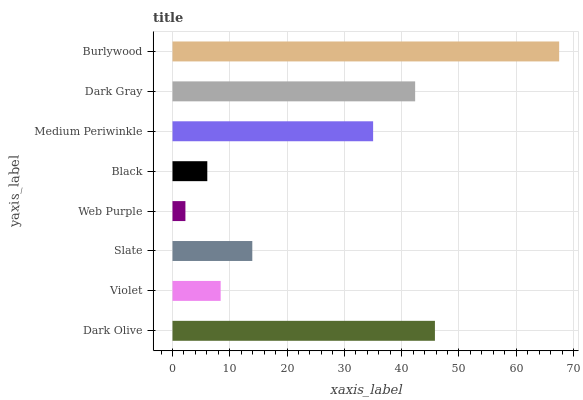Is Web Purple the minimum?
Answer yes or no. Yes. Is Burlywood the maximum?
Answer yes or no. Yes. Is Violet the minimum?
Answer yes or no. No. Is Violet the maximum?
Answer yes or no. No. Is Dark Olive greater than Violet?
Answer yes or no. Yes. Is Violet less than Dark Olive?
Answer yes or no. Yes. Is Violet greater than Dark Olive?
Answer yes or no. No. Is Dark Olive less than Violet?
Answer yes or no. No. Is Medium Periwinkle the high median?
Answer yes or no. Yes. Is Slate the low median?
Answer yes or no. Yes. Is Slate the high median?
Answer yes or no. No. Is Medium Periwinkle the low median?
Answer yes or no. No. 